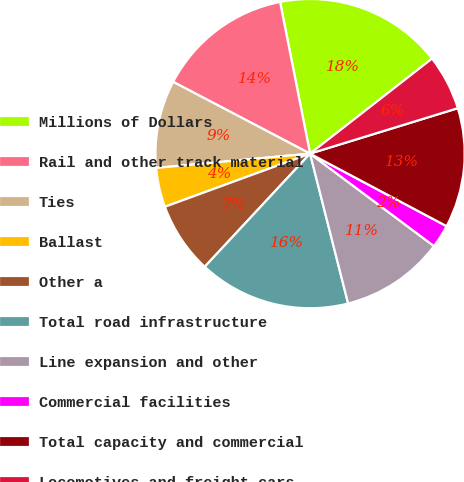<chart> <loc_0><loc_0><loc_500><loc_500><pie_chart><fcel>Millions of Dollars<fcel>Rail and other track material<fcel>Ties<fcel>Ballast<fcel>Other a<fcel>Total road infrastructure<fcel>Line expansion and other<fcel>Commercial facilities<fcel>Total capacity and commercial<fcel>Locomotives and freight cars<nl><fcel>17.57%<fcel>14.21%<fcel>9.16%<fcel>4.11%<fcel>7.48%<fcel>15.89%<fcel>10.84%<fcel>2.43%<fcel>12.52%<fcel>5.79%<nl></chart> 